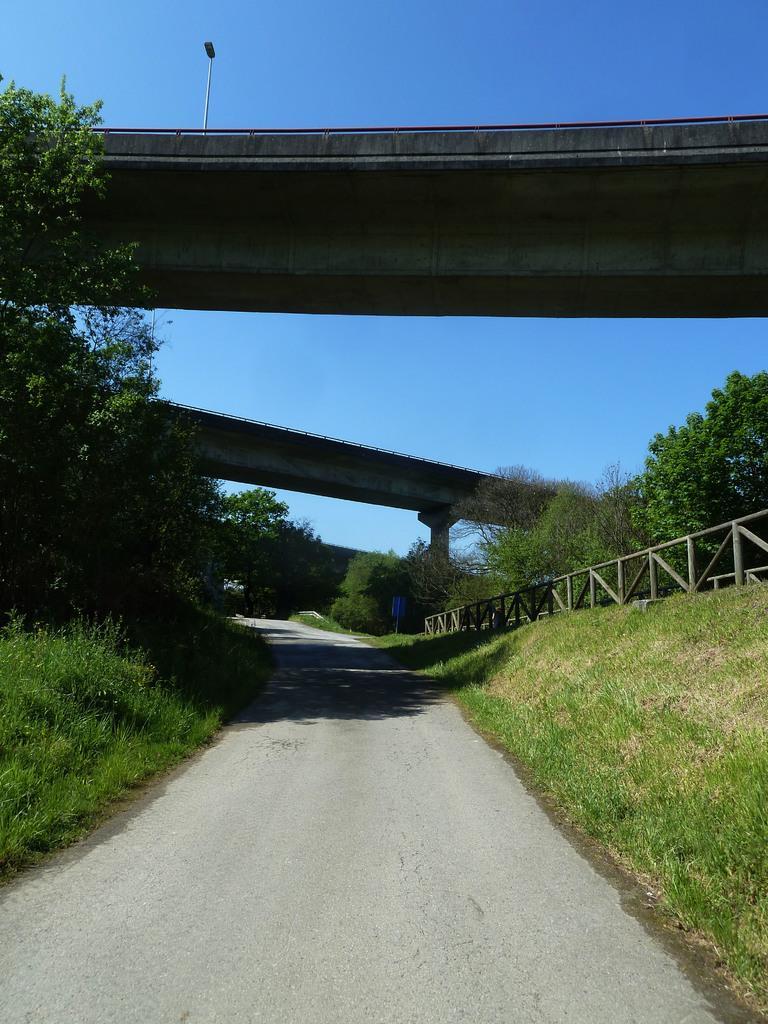Can you describe this image briefly? In the center of the image we can see two bridges. On the right side of the image we can see a fence. In the background, we can see a group of trees and the sky. 